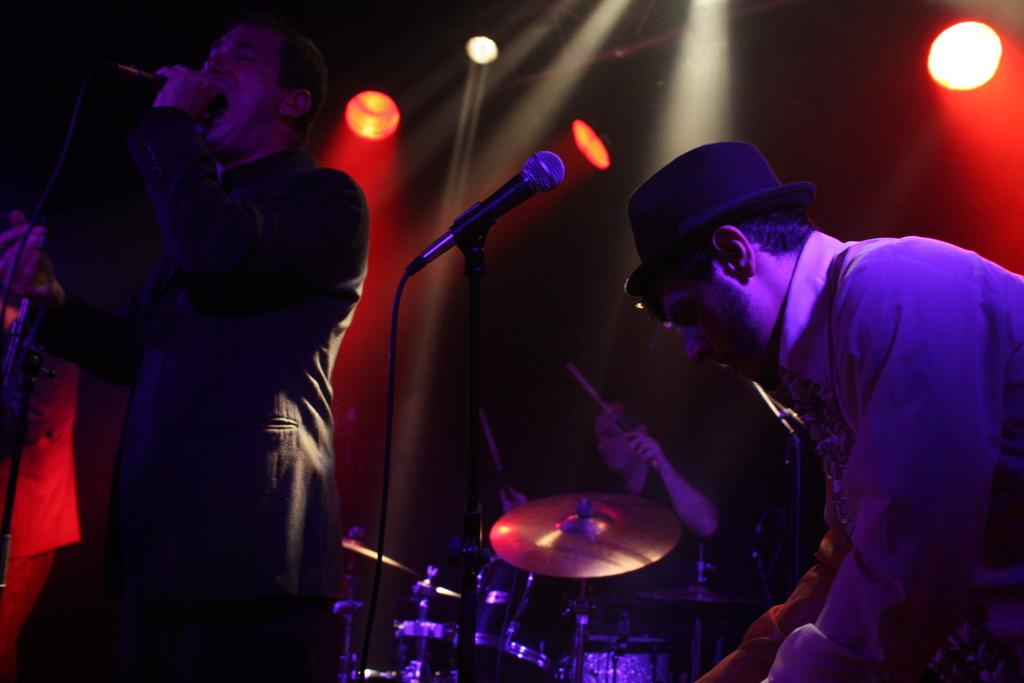Who or what can be seen in the image? There are people in the image. What objects are associated with the people in the image? Microphones and musical instruments are visible in the image. What can be seen at the top of the image? There are lights at the top of the image. What type of hateful message is being written on the church in the image? There is no church or writing present in the image, so it is not possible to determine if any hateful message is being written. 